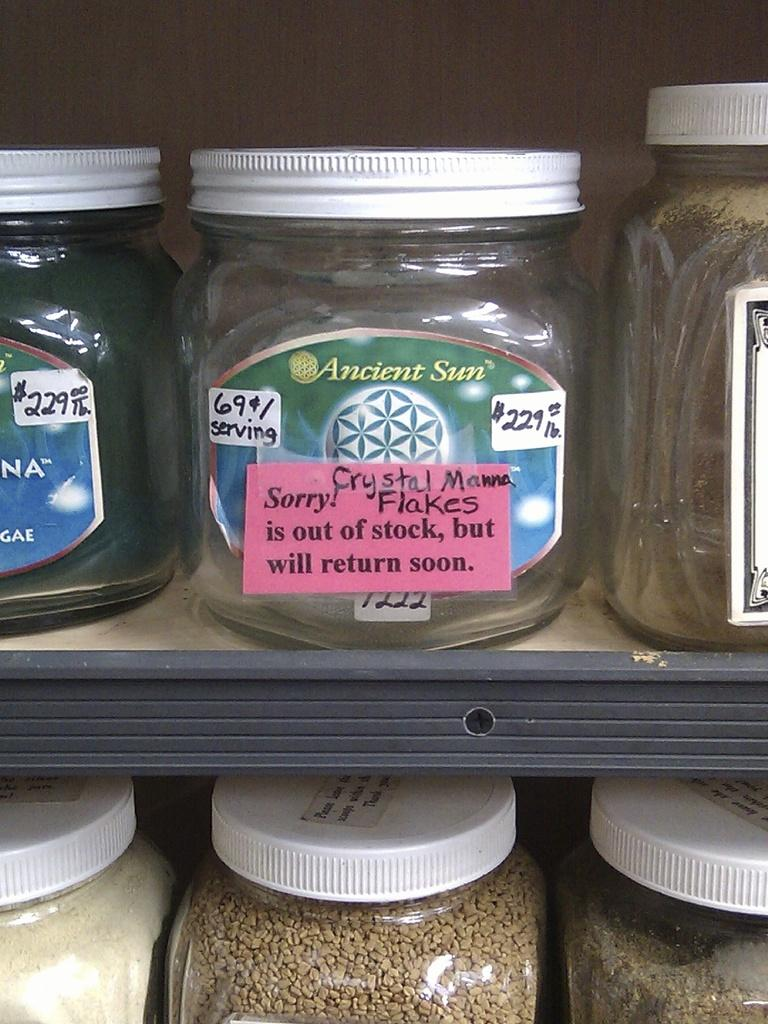<image>
Summarize the visual content of the image. a jar of Ancient Sun flakes are out of stock 